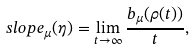<formula> <loc_0><loc_0><loc_500><loc_500>s l o p e _ { \mu } ( \eta ) = \lim _ { t \to \infty } \frac { b _ { \mu } ( \rho ( t ) ) } { t } ,</formula> 